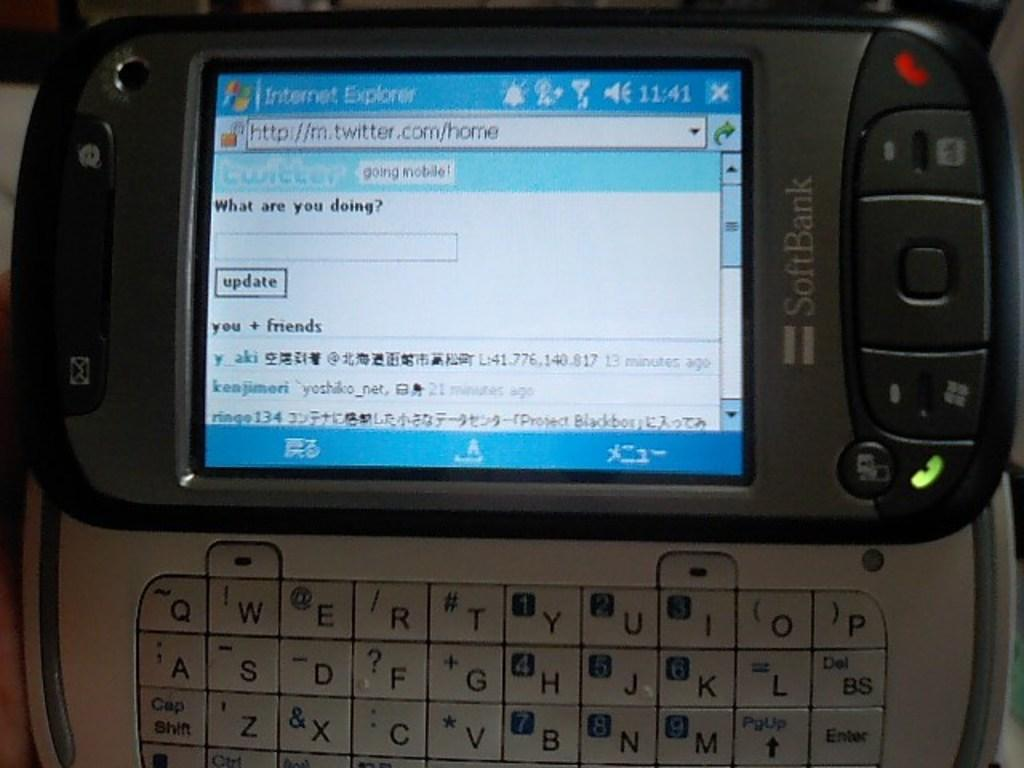<image>
Offer a succinct explanation of the picture presented. "What are you doing?" reads the Twitter feed on this personal organizer. 